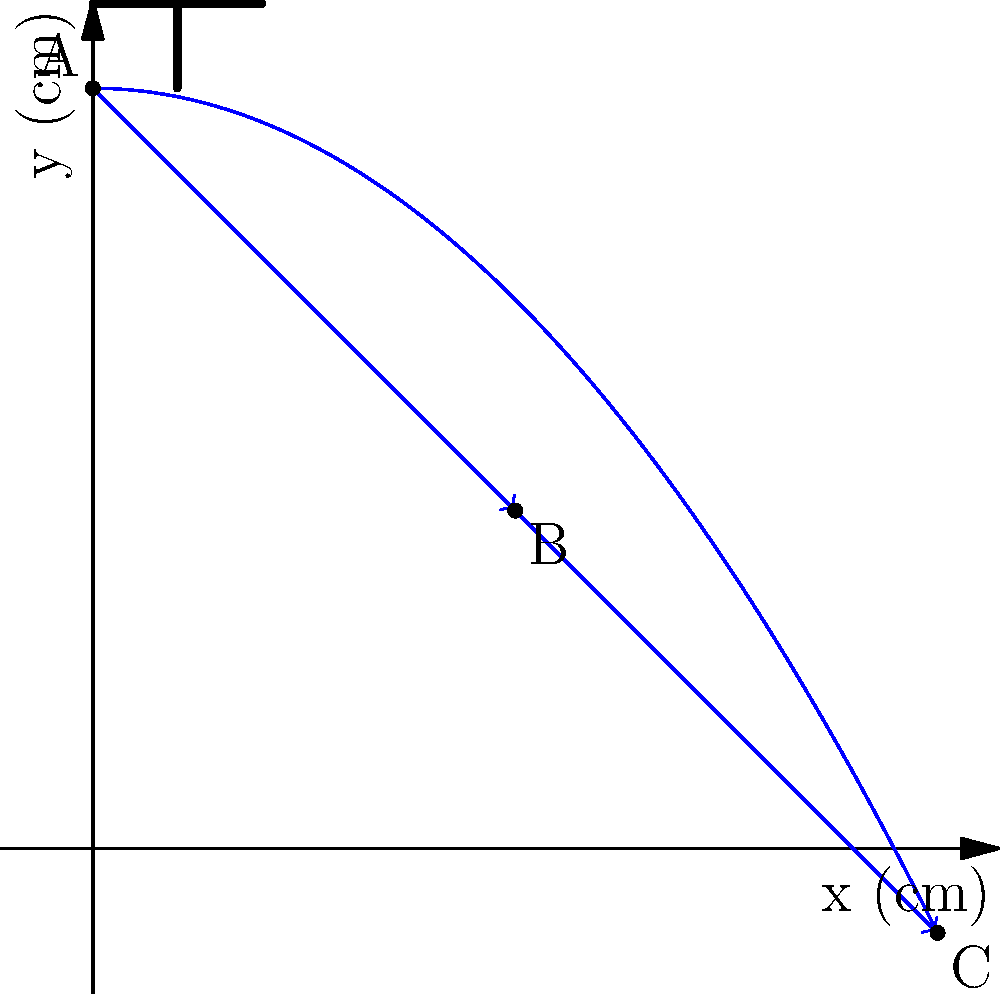In a children's hygiene workshop, you're demonstrating the importance of hand washing using a faucet model. The trajectory of water droplets from the faucet is represented by vectors. If vector $\vec{AB}$ represents the first half of the trajectory and $\vec{BC}$ represents the second half, what is the magnitude of the resultant vector $\vec{AC}$ in centimeters? Let's approach this step-by-step:

1) First, we need to determine the components of vectors $\vec{AB}$ and $\vec{BC}$.

   $\vec{AB}$: From (0,9) to (5,4)
   $\vec{AB} = (5-0, 4-9) = (5, -5)$

   $\vec{BC}$: From (5,4) to (10,-1)
   $\vec{BC} = (10-5, -1-4) = (5, -5)$

2) The resultant vector $\vec{AC}$ is the sum of these two vectors:
   $\vec{AC} = \vec{AB} + \vec{BC} = (5, -5) + (5, -5) = (10, -10)$

3) To find the magnitude of $\vec{AC}$, we use the Pythagorean theorem:

   $|\vec{AC}| = \sqrt{(10)^2 + (-10)^2}$

4) Simplify:
   $|\vec{AC}| = \sqrt{100 + 100} = \sqrt{200}$

5) Simplify the square root:
   $|\vec{AC}| = 10\sqrt{2}$ cm

Therefore, the magnitude of the resultant vector $\vec{AC}$ is $10\sqrt{2}$ cm.
Answer: $10\sqrt{2}$ cm 